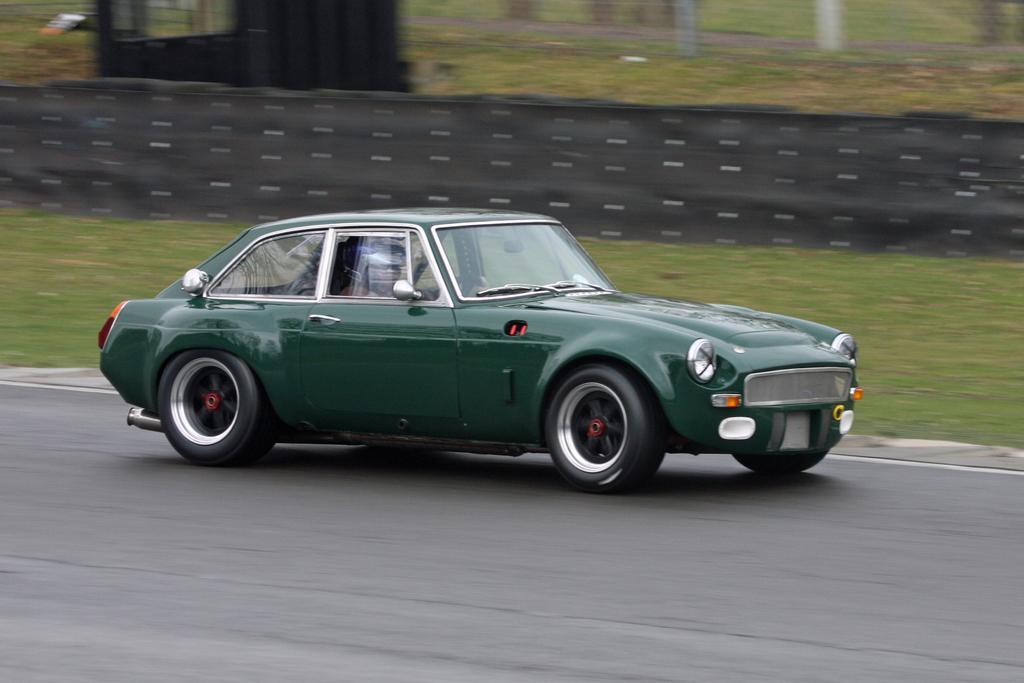What color is the car in the image? The car in the image is green. What is the car doing in the image? The car is moving on the road. Can you describe the background of the image? The background of the image is slightly blurred. What type of vegetation can be seen in the background? There is grass visible in the background of the image. What type of bone is visible in the image? There is no bone present in the image; it features a green car moving on the road with a blurred background and visible grass. 